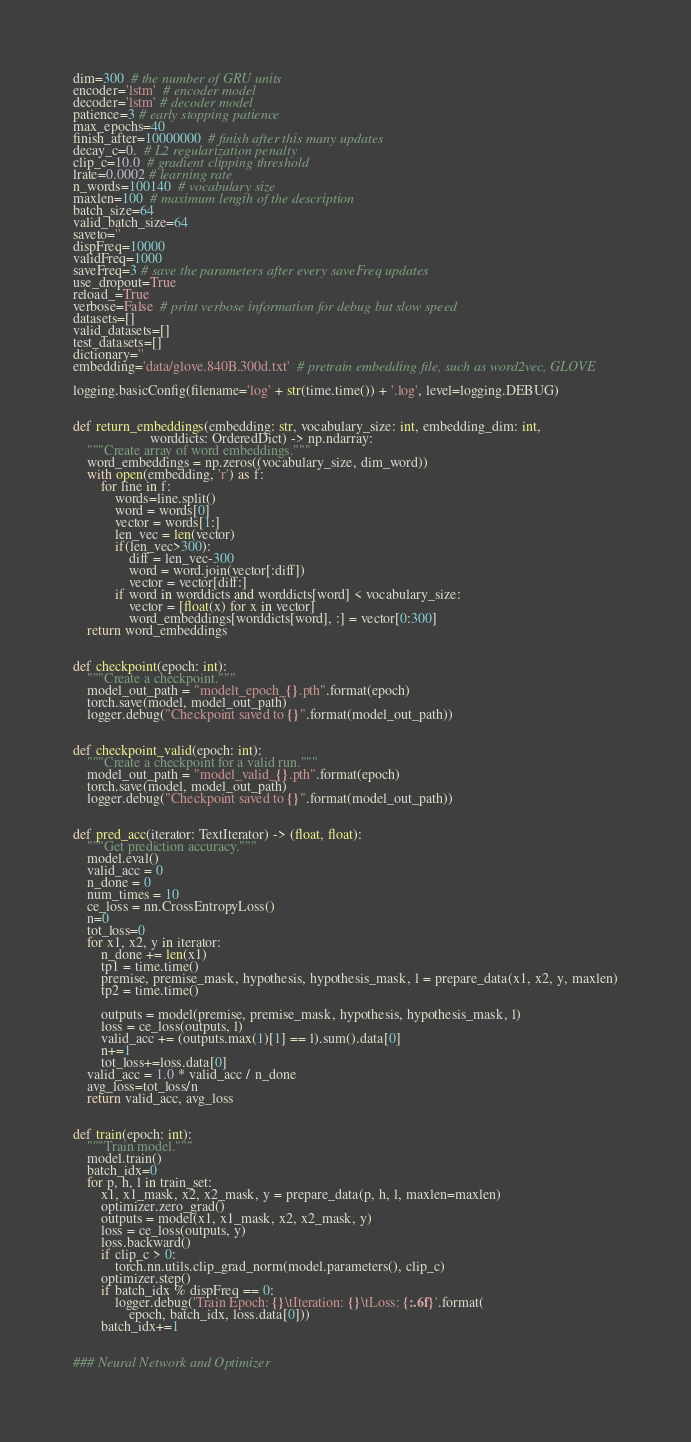<code> <loc_0><loc_0><loc_500><loc_500><_Python_>dim=300  # the number of GRU units
encoder='lstm'  # encoder model
decoder='lstm' # decoder model
patience=3 # early stopping patience
max_epochs=40
finish_after=10000000  # finish after this many updates
decay_c=0.  # L2 regularization penalty
clip_c=10.0  # gradient clipping threshold
lrate=0.0002 # learning rate
n_words=100140  # vocabulary size
maxlen=100  # maximum length of the description
batch_size=64
valid_batch_size=64
saveto=''
dispFreq=10000
validFreq=1000
saveFreq=3 # save the parameters after every saveFreq updates
use_dropout=True
reload_=True
verbose=False  # print verbose information for debug but slow speed
datasets=[]
valid_datasets=[]
test_datasets=[]
dictionary=''
embedding='data/glove.840B.300d.txt'  # pretrain embedding file, such as word2vec, GLOVE

logging.basicConfig(filename='log' + str(time.time()) + '.log', level=logging.DEBUG)


def return_embeddings(embedding: str, vocabulary_size: int, embedding_dim: int,
                      worddicts: OrderedDict) -> np.ndarray:
    """Create array of word embeddings."""
    word_embeddings = np.zeros((vocabulary_size, dim_word))
    with open(embedding, 'r') as f:
        for line in f:
            words=line.split()
            word = words[0]
            vector = words[1:]
            len_vec = len(vector)
            if(len_vec>300):
                diff = len_vec-300
                word = word.join(vector[:diff])
                vector = vector[diff:]
            if word in worddicts and worddicts[word] < vocabulary_size:
                vector = [float(x) for x in vector]
                word_embeddings[worddicts[word], :] = vector[0:300]
    return word_embeddings


def checkpoint(epoch: int):
    """Create a checkpoint."""
    model_out_path = "modelt_epoch_{}.pth".format(epoch)
    torch.save(model, model_out_path)
    logger.debug("Checkpoint saved to {}".format(model_out_path))


def checkpoint_valid(epoch: int):
    """Create a checkpoint for a valid run."""
    model_out_path = "model_valid_{}.pth".format(epoch)
    torch.save(model, model_out_path)
    logger.debug("Checkpoint saved to {}".format(model_out_path))


def pred_acc(iterator: TextIterator) -> (float, float):
    """Get prediction accuracy."""
    model.eval()
    valid_acc = 0
    n_done = 0
    num_times = 10
    ce_loss = nn.CrossEntropyLoss()
    n=0
    tot_loss=0
    for x1, x2, y in iterator:
        n_done += len(x1)
        tp1 = time.time()
        premise, premise_mask, hypothesis, hypothesis_mask, l = prepare_data(x1, x2, y, maxlen)
        tp2 = time.time()

        outputs = model(premise, premise_mask, hypothesis, hypothesis_mask, l)
        loss = ce_loss(outputs, l)
        valid_acc += (outputs.max(1)[1] == l).sum().data[0]
        n+=1
        tot_loss+=loss.data[0]
    valid_acc = 1.0 * valid_acc / n_done
    avg_loss=tot_loss/n
    return valid_acc, avg_loss


def train(epoch: int):
    """Train model."""
    model.train()
    batch_idx=0
    for p, h, l in train_set:
        x1, x1_mask, x2, x2_mask, y = prepare_data(p, h, l, maxlen=maxlen)
        optimizer.zero_grad()
        outputs = model(x1, x1_mask, x2, x2_mask, y)
        loss = ce_loss(outputs, y)
        loss.backward()
        if clip_c > 0:
            torch.nn.utils.clip_grad_norm(model.parameters(), clip_c)
        optimizer.step()
        if batch_idx % dispFreq == 0:
            logger.debug('Train Epoch: {}\tIteration: {}\tLoss: {:.6f}'.format(
                epoch, batch_idx, loss.data[0]))
        batch_idx+=1


### Neural Network and Optimizer</code> 